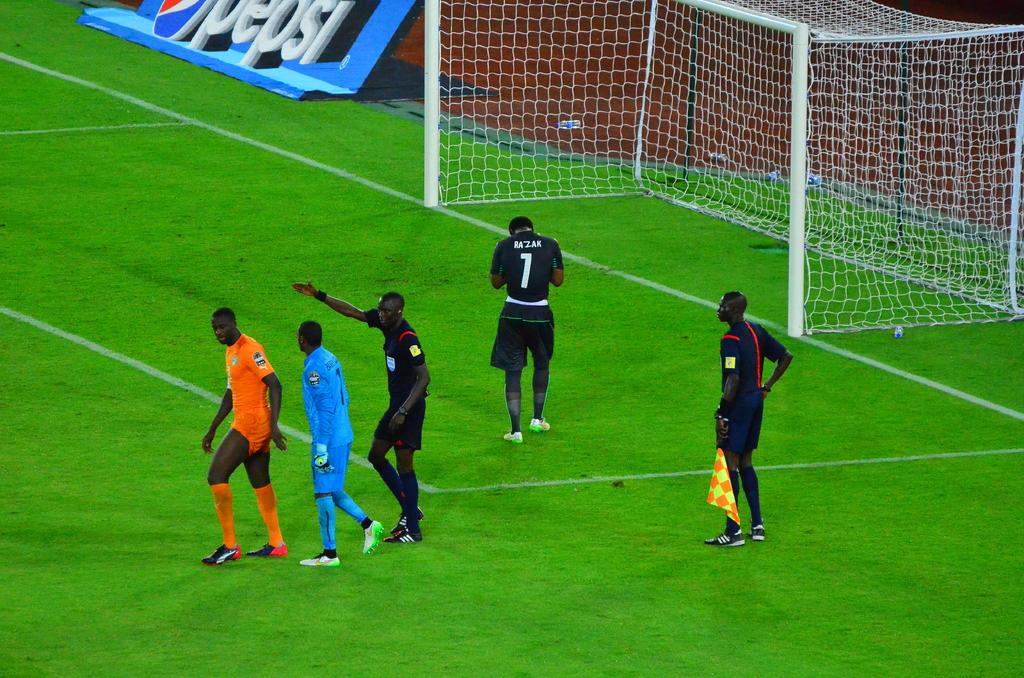<image>
Relay a brief, clear account of the picture shown. Soccer players interact on the field near a huge Pepsi advertising display. 